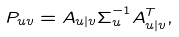<formula> <loc_0><loc_0><loc_500><loc_500>P _ { u v } & = A _ { u | v } \Sigma _ { u } ^ { - 1 } A _ { u | v } ^ { T } ,</formula> 